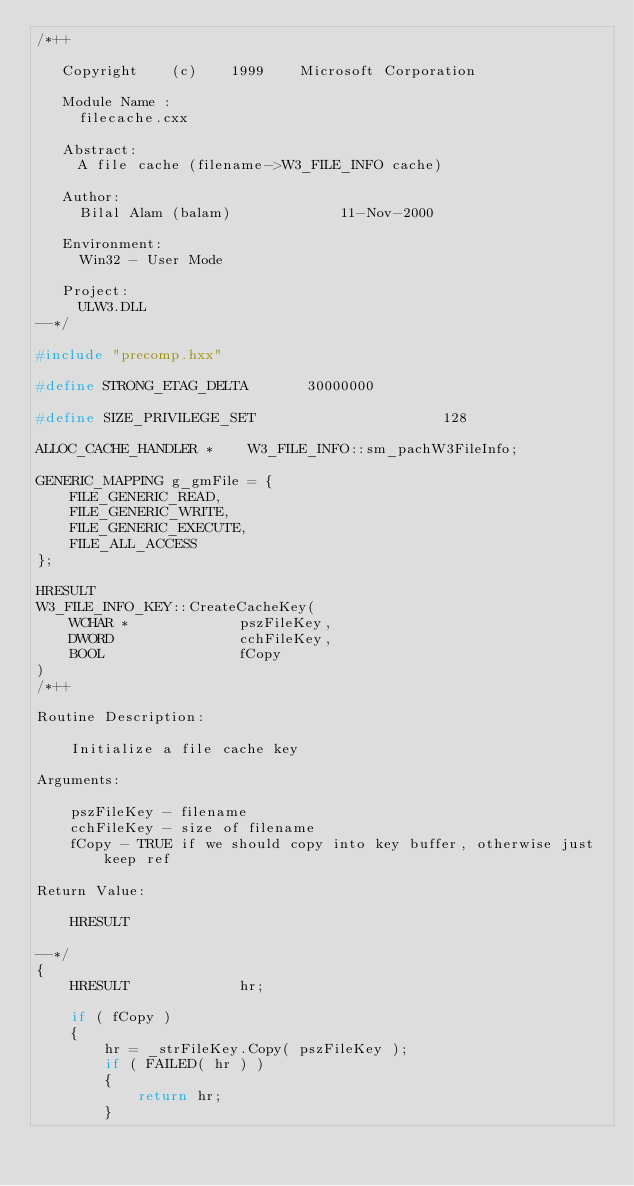<code> <loc_0><loc_0><loc_500><loc_500><_C++_>/*++

   Copyright    (c)    1999    Microsoft Corporation

   Module Name :
     filecache.cxx

   Abstract:
     A file cache (filename->W3_FILE_INFO cache)
 
   Author:
     Bilal Alam (balam)             11-Nov-2000

   Environment:
     Win32 - User Mode

   Project:
     ULW3.DLL
--*/

#include "precomp.hxx"

#define STRONG_ETAG_DELTA       30000000

#define SIZE_PRIVILEGE_SET                      128

ALLOC_CACHE_HANDLER *    W3_FILE_INFO::sm_pachW3FileInfo;

GENERIC_MAPPING g_gmFile = {
    FILE_GENERIC_READ,
    FILE_GENERIC_WRITE,
    FILE_GENERIC_EXECUTE,
    FILE_ALL_ACCESS
};

HRESULT
W3_FILE_INFO_KEY::CreateCacheKey(
    WCHAR *             pszFileKey,
    DWORD               cchFileKey,
    BOOL                fCopy
)
/*++

Routine Description:

    Initialize a file cache key

Arguments:

    pszFileKey - filename
    cchFileKey - size of filename
    fCopy - TRUE if we should copy into key buffer, otherwise just keep ref

Return Value:

    HRESULT

--*/
{
    HRESULT             hr;
    
    if ( fCopy )
    {
        hr = _strFileKey.Copy( pszFileKey );
        if ( FAILED( hr ) )
        {
            return hr;
        }</code> 